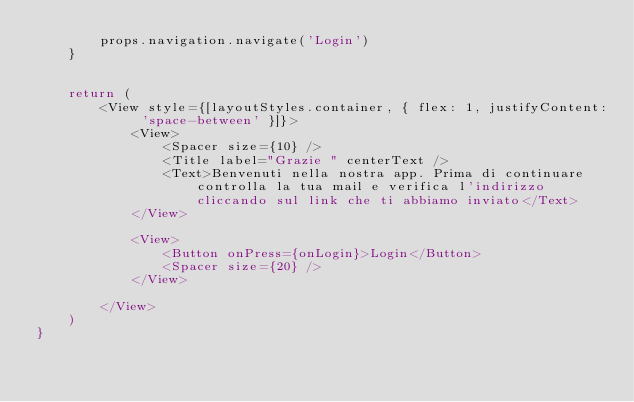<code> <loc_0><loc_0><loc_500><loc_500><_JavaScript_>        props.navigation.navigate('Login')
    }


    return (
        <View style={[layoutStyles.container, { flex: 1, justifyContent: 'space-between' }]}>
            <View>
                <Spacer size={10} />
                <Title label="Grazie " centerText />
                <Text>Benvenuti nella nostra app. Prima di continuare controlla la tua mail e verifica l'indirizzo cliccando sul link che ti abbiamo inviato</Text>
            </View>

            <View>
                <Button onPress={onLogin}>Login</Button>
                <Spacer size={20} />
            </View>

        </View>
    )
}
</code> 